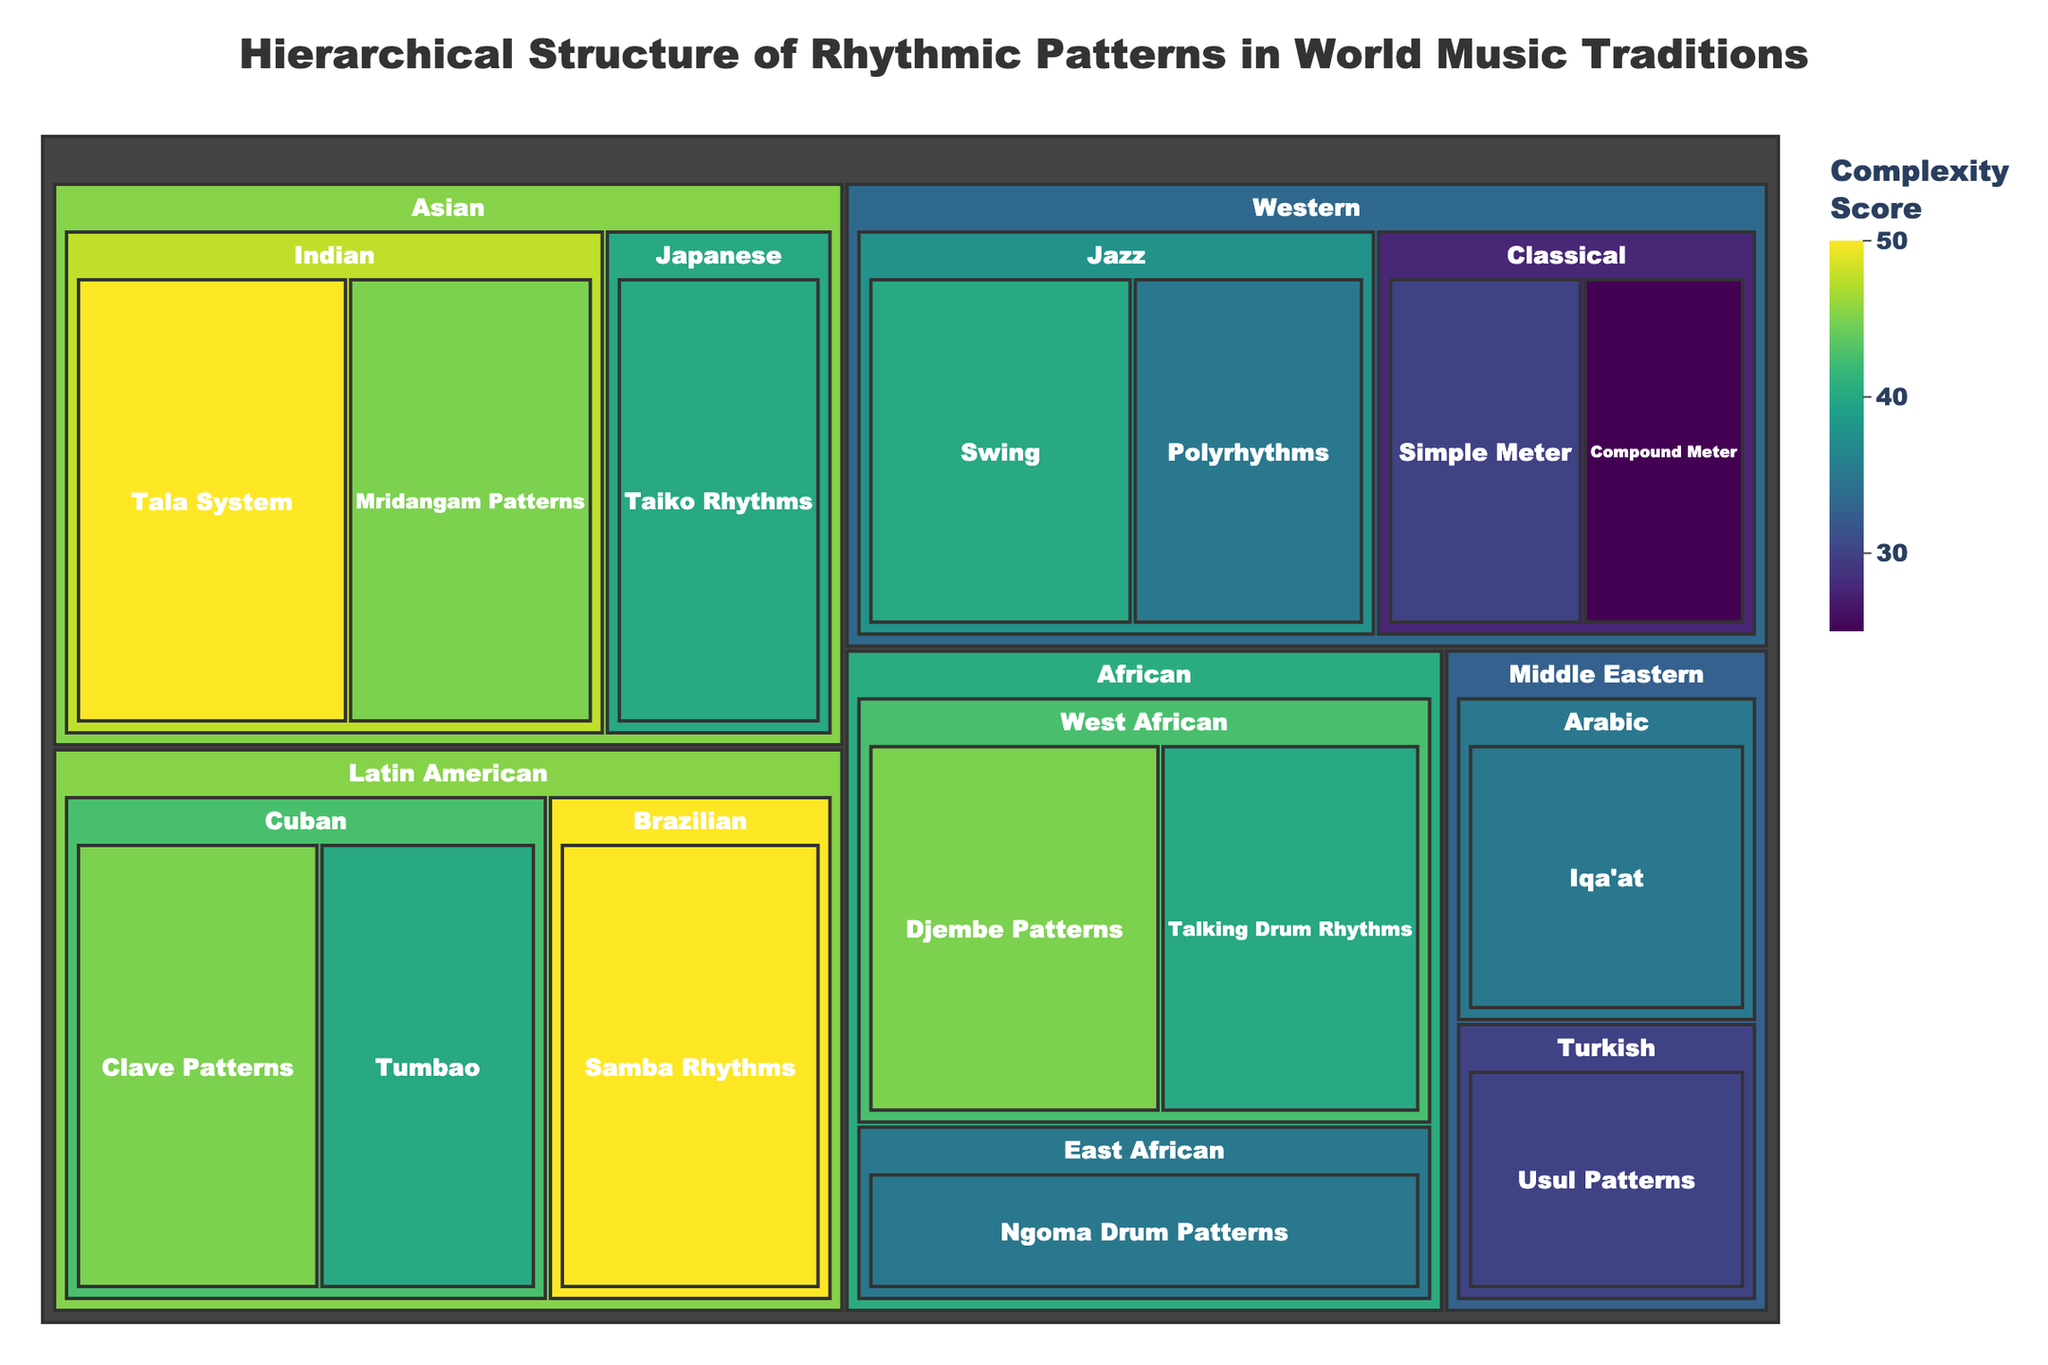Which rhythmic pattern has the highest complexity score? The highest complexity score can be seen in the element with the largest area on the treemap and the darkest color.
Answer: Tala System (Indian) How many elements are in the Western music category? By examining the subdivisions under the "Western" category, which are Classical and Jazz, we count the elements within them.
Answer: 4 What's the total complexity score for African rhythmic patterns? Add the values of all elements under the African category: Djembe Patterns (45) + Talking Drum Rhythms (40) + Ngoma Drum Patterns (35).
Answer: 120 Which has a higher complexity score: Samba Rhythms or Clave Patterns? Compare the scores of Samba Rhythms (50) and Clave Patterns (45) as represented by their sizes and colors in the treemap.
Answer: Samba Rhythms What is the average complexity score for Middle Eastern rhythms? Add the complexity scores of Iqa'at (35) and Usul Patterns (30), then divide by the number of elements: (35 + 30) / 2.
Answer: 32.5 Which subcategory within the Asian category has the highest complexity score, and what is it? Compare the values of rhythmic patterns in Indian and Japanese subcategories within the Asian category.
Answer: Tala System (50) How does the complexity of Ngoma Drum Patterns compare to Tumbao? Compare the complexity scores of Ngoma Drum Patterns (35) and Tumbao (40).
Answer: Tumbao is higher What is the sum of complexity scores for the Japanese and Cuban subcategories? Add the scores of Japanese (40) and Cuban (45 + 40).
Answer: 125 Which world music tradition has the most subcategories? Count the subcategories under each main category: Western (2), African (2), Asian (2), Latin American (2), and Middle Eastern (2).
Answer: All have equal subcategories (2 each) What's the difference in complexity score between Swing and Polyrhythms in Jazz? Subtract the complexity score of Polyrhythms (35) from Swing (40).
Answer: 5 